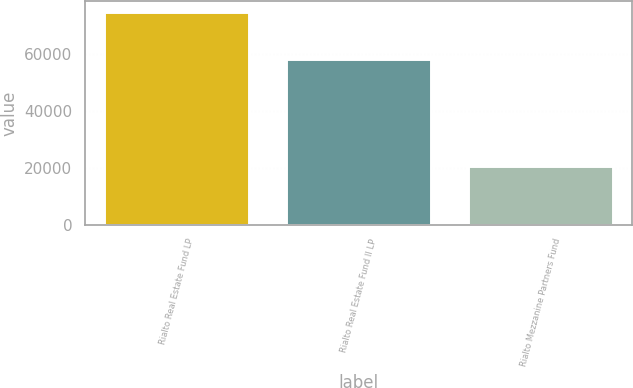<chart> <loc_0><loc_0><loc_500><loc_500><bar_chart><fcel>Rialto Real Estate Fund LP<fcel>Rialto Real Estate Fund II LP<fcel>Rialto Mezzanine Partners Fund<nl><fcel>75000<fcel>58242<fcel>20504<nl></chart> 